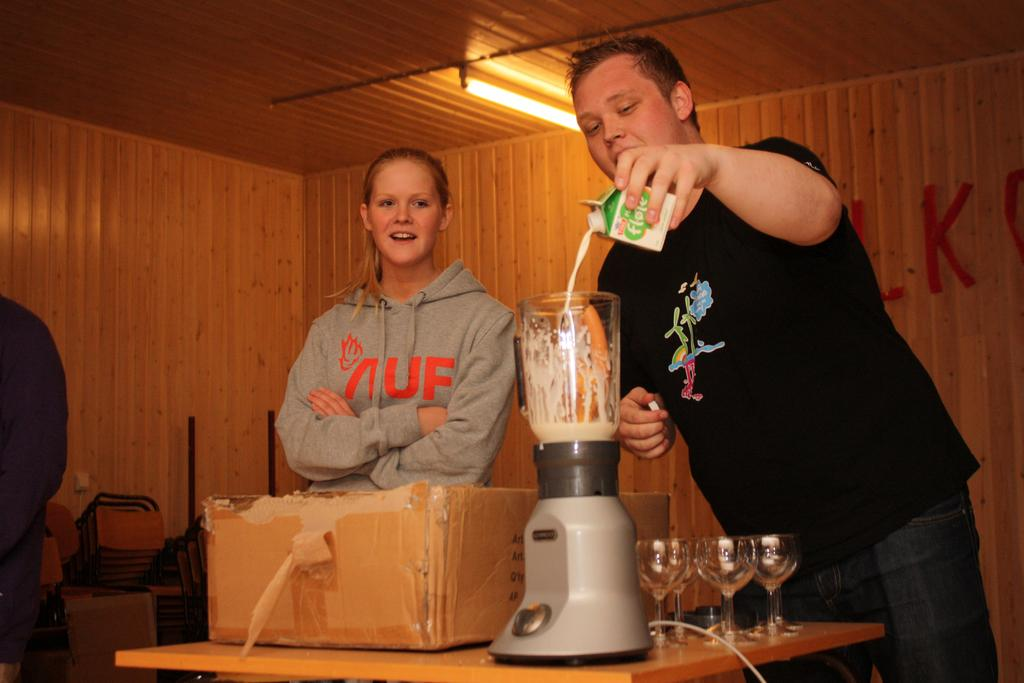<image>
Describe the image concisely. Two people in a wood paneled room with the girl on the left wearing a grey sweatshirt labeled "UF" 